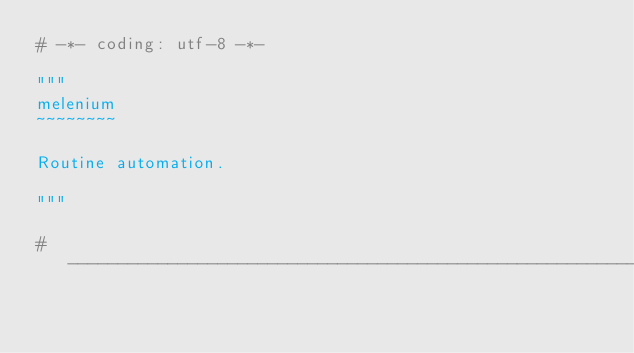<code> <loc_0><loc_0><loc_500><loc_500><_Python_># -*- coding: utf-8 -*-

"""
melenium
~~~~~~~~

Routine automation.

"""

#-----------------------------------------------------------------------------
</code> 